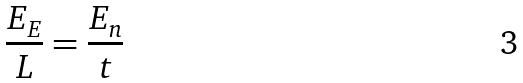<formula> <loc_0><loc_0><loc_500><loc_500>\frac { E _ { E } } { L } = \frac { E _ { n } } { t }</formula> 